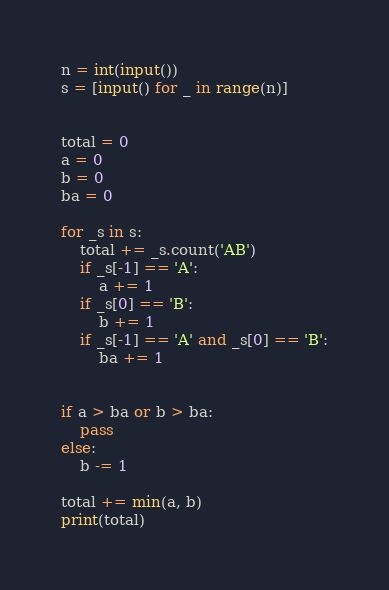<code> <loc_0><loc_0><loc_500><loc_500><_Python_>n = int(input())
s = [input() for _ in range(n)]


total = 0
a = 0
b = 0
ba = 0

for _s in s:
    total += _s.count('AB')
    if _s[-1] == 'A':
        a += 1
    if _s[0] == 'B':
        b += 1
    if _s[-1] == 'A' and _s[0] == 'B':
        ba += 1


if a > ba or b > ba:
    pass
else:
    b -= 1

total += min(a, b)
print(total)
</code> 